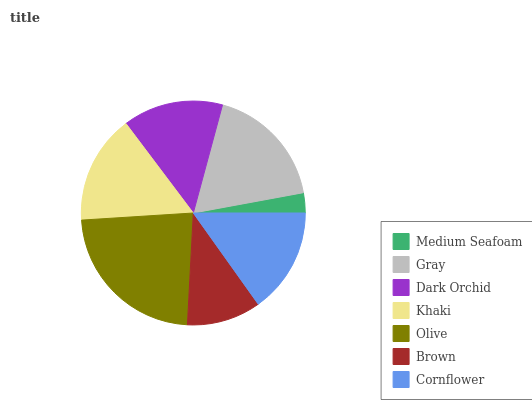Is Medium Seafoam the minimum?
Answer yes or no. Yes. Is Olive the maximum?
Answer yes or no. Yes. Is Gray the minimum?
Answer yes or no. No. Is Gray the maximum?
Answer yes or no. No. Is Gray greater than Medium Seafoam?
Answer yes or no. Yes. Is Medium Seafoam less than Gray?
Answer yes or no. Yes. Is Medium Seafoam greater than Gray?
Answer yes or no. No. Is Gray less than Medium Seafoam?
Answer yes or no. No. Is Cornflower the high median?
Answer yes or no. Yes. Is Cornflower the low median?
Answer yes or no. Yes. Is Dark Orchid the high median?
Answer yes or no. No. Is Khaki the low median?
Answer yes or no. No. 